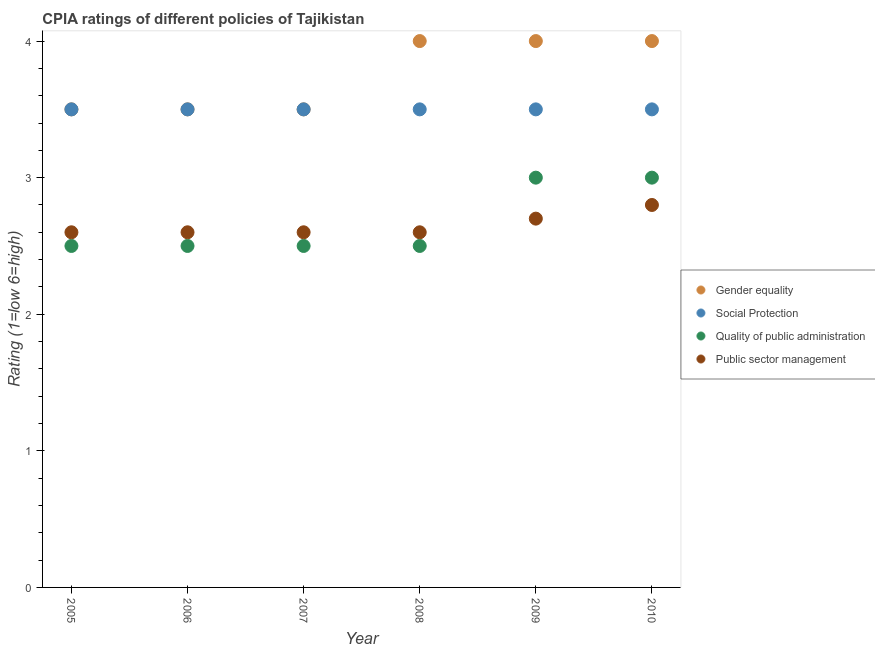What is the cpia rating of social protection in 2010?
Ensure brevity in your answer.  3.5. In which year was the cpia rating of quality of public administration minimum?
Provide a succinct answer. 2005. What is the total cpia rating of gender equality in the graph?
Offer a terse response. 22.5. What is the difference between the cpia rating of social protection in 2006 and that in 2009?
Offer a very short reply. 0. What is the difference between the cpia rating of social protection in 2007 and the cpia rating of public sector management in 2008?
Ensure brevity in your answer.  0.9. What is the average cpia rating of gender equality per year?
Make the answer very short. 3.75. In the year 2008, what is the difference between the cpia rating of social protection and cpia rating of public sector management?
Provide a succinct answer. 0.9. Is the cpia rating of social protection in 2008 less than that in 2010?
Give a very brief answer. No. Is the difference between the cpia rating of gender equality in 2005 and 2007 greater than the difference between the cpia rating of public sector management in 2005 and 2007?
Provide a short and direct response. No. What is the difference between the highest and the second highest cpia rating of quality of public administration?
Offer a very short reply. 0. In how many years, is the cpia rating of social protection greater than the average cpia rating of social protection taken over all years?
Your response must be concise. 0. Is the sum of the cpia rating of public sector management in 2005 and 2008 greater than the maximum cpia rating of social protection across all years?
Your answer should be compact. Yes. Is it the case that in every year, the sum of the cpia rating of gender equality and cpia rating of quality of public administration is greater than the sum of cpia rating of social protection and cpia rating of public sector management?
Your answer should be compact. Yes. Is it the case that in every year, the sum of the cpia rating of gender equality and cpia rating of social protection is greater than the cpia rating of quality of public administration?
Your answer should be very brief. Yes. Does the cpia rating of gender equality monotonically increase over the years?
Ensure brevity in your answer.  No. Is the cpia rating of public sector management strictly greater than the cpia rating of gender equality over the years?
Offer a very short reply. No. Is the cpia rating of quality of public administration strictly less than the cpia rating of gender equality over the years?
Make the answer very short. Yes. How many years are there in the graph?
Your answer should be very brief. 6. What is the difference between two consecutive major ticks on the Y-axis?
Offer a terse response. 1. Does the graph contain grids?
Provide a succinct answer. No. How many legend labels are there?
Your answer should be compact. 4. What is the title of the graph?
Offer a very short reply. CPIA ratings of different policies of Tajikistan. What is the label or title of the X-axis?
Keep it short and to the point. Year. What is the label or title of the Y-axis?
Ensure brevity in your answer.  Rating (1=low 6=high). What is the Rating (1=low 6=high) of Social Protection in 2005?
Give a very brief answer. 3.5. What is the Rating (1=low 6=high) of Gender equality in 2006?
Your answer should be compact. 3.5. What is the Rating (1=low 6=high) of Social Protection in 2007?
Your answer should be compact. 3.5. What is the Rating (1=low 6=high) in Gender equality in 2008?
Your answer should be very brief. 4. What is the Rating (1=low 6=high) in Social Protection in 2008?
Give a very brief answer. 3.5. What is the Rating (1=low 6=high) in Quality of public administration in 2008?
Offer a very short reply. 2.5. What is the Rating (1=low 6=high) of Public sector management in 2008?
Keep it short and to the point. 2.6. What is the Rating (1=low 6=high) in Social Protection in 2009?
Provide a short and direct response. 3.5. What is the Rating (1=low 6=high) in Social Protection in 2010?
Keep it short and to the point. 3.5. What is the Rating (1=low 6=high) in Quality of public administration in 2010?
Ensure brevity in your answer.  3. Across all years, what is the maximum Rating (1=low 6=high) of Gender equality?
Provide a short and direct response. 4. Across all years, what is the minimum Rating (1=low 6=high) in Public sector management?
Make the answer very short. 2.6. What is the total Rating (1=low 6=high) of Gender equality in the graph?
Provide a succinct answer. 22.5. What is the total Rating (1=low 6=high) in Social Protection in the graph?
Provide a succinct answer. 21. What is the total Rating (1=low 6=high) of Public sector management in the graph?
Provide a short and direct response. 15.9. What is the difference between the Rating (1=low 6=high) in Social Protection in 2005 and that in 2006?
Offer a very short reply. 0. What is the difference between the Rating (1=low 6=high) of Quality of public administration in 2005 and that in 2006?
Provide a short and direct response. 0. What is the difference between the Rating (1=low 6=high) in Gender equality in 2005 and that in 2007?
Make the answer very short. 0. What is the difference between the Rating (1=low 6=high) of Public sector management in 2005 and that in 2007?
Offer a terse response. 0. What is the difference between the Rating (1=low 6=high) of Social Protection in 2005 and that in 2008?
Provide a succinct answer. 0. What is the difference between the Rating (1=low 6=high) in Public sector management in 2005 and that in 2008?
Provide a short and direct response. 0. What is the difference between the Rating (1=low 6=high) of Gender equality in 2005 and that in 2009?
Provide a short and direct response. -0.5. What is the difference between the Rating (1=low 6=high) of Social Protection in 2005 and that in 2009?
Provide a succinct answer. 0. What is the difference between the Rating (1=low 6=high) of Quality of public administration in 2005 and that in 2009?
Provide a short and direct response. -0.5. What is the difference between the Rating (1=low 6=high) of Quality of public administration in 2005 and that in 2010?
Offer a terse response. -0.5. What is the difference between the Rating (1=low 6=high) of Public sector management in 2005 and that in 2010?
Give a very brief answer. -0.2. What is the difference between the Rating (1=low 6=high) in Gender equality in 2006 and that in 2007?
Your answer should be compact. 0. What is the difference between the Rating (1=low 6=high) of Social Protection in 2006 and that in 2007?
Your answer should be very brief. 0. What is the difference between the Rating (1=low 6=high) of Quality of public administration in 2006 and that in 2008?
Your answer should be very brief. 0. What is the difference between the Rating (1=low 6=high) of Public sector management in 2006 and that in 2008?
Your answer should be very brief. 0. What is the difference between the Rating (1=low 6=high) of Gender equality in 2006 and that in 2009?
Your answer should be very brief. -0.5. What is the difference between the Rating (1=low 6=high) in Quality of public administration in 2006 and that in 2009?
Give a very brief answer. -0.5. What is the difference between the Rating (1=low 6=high) in Public sector management in 2006 and that in 2009?
Give a very brief answer. -0.1. What is the difference between the Rating (1=low 6=high) in Quality of public administration in 2007 and that in 2008?
Provide a short and direct response. 0. What is the difference between the Rating (1=low 6=high) of Gender equality in 2007 and that in 2009?
Offer a terse response. -0.5. What is the difference between the Rating (1=low 6=high) of Social Protection in 2007 and that in 2009?
Your response must be concise. 0. What is the difference between the Rating (1=low 6=high) of Quality of public administration in 2007 and that in 2010?
Offer a very short reply. -0.5. What is the difference between the Rating (1=low 6=high) in Public sector management in 2007 and that in 2010?
Ensure brevity in your answer.  -0.2. What is the difference between the Rating (1=low 6=high) of Social Protection in 2008 and that in 2009?
Offer a terse response. 0. What is the difference between the Rating (1=low 6=high) of Quality of public administration in 2008 and that in 2009?
Your response must be concise. -0.5. What is the difference between the Rating (1=low 6=high) in Gender equality in 2008 and that in 2010?
Provide a succinct answer. 0. What is the difference between the Rating (1=low 6=high) of Social Protection in 2009 and that in 2010?
Keep it short and to the point. 0. What is the difference between the Rating (1=low 6=high) of Gender equality in 2005 and the Rating (1=low 6=high) of Social Protection in 2006?
Provide a short and direct response. 0. What is the difference between the Rating (1=low 6=high) of Quality of public administration in 2005 and the Rating (1=low 6=high) of Public sector management in 2006?
Provide a short and direct response. -0.1. What is the difference between the Rating (1=low 6=high) in Gender equality in 2005 and the Rating (1=low 6=high) in Social Protection in 2007?
Your answer should be very brief. 0. What is the difference between the Rating (1=low 6=high) in Social Protection in 2005 and the Rating (1=low 6=high) in Public sector management in 2007?
Your response must be concise. 0.9. What is the difference between the Rating (1=low 6=high) of Quality of public administration in 2005 and the Rating (1=low 6=high) of Public sector management in 2007?
Make the answer very short. -0.1. What is the difference between the Rating (1=low 6=high) of Gender equality in 2005 and the Rating (1=low 6=high) of Public sector management in 2008?
Provide a short and direct response. 0.9. What is the difference between the Rating (1=low 6=high) of Gender equality in 2005 and the Rating (1=low 6=high) of Social Protection in 2009?
Your answer should be very brief. 0. What is the difference between the Rating (1=low 6=high) of Gender equality in 2005 and the Rating (1=low 6=high) of Quality of public administration in 2009?
Provide a short and direct response. 0.5. What is the difference between the Rating (1=low 6=high) of Gender equality in 2005 and the Rating (1=low 6=high) of Public sector management in 2009?
Provide a succinct answer. 0.8. What is the difference between the Rating (1=low 6=high) of Quality of public administration in 2005 and the Rating (1=low 6=high) of Public sector management in 2009?
Your answer should be compact. -0.2. What is the difference between the Rating (1=low 6=high) of Gender equality in 2005 and the Rating (1=low 6=high) of Social Protection in 2010?
Provide a succinct answer. 0. What is the difference between the Rating (1=low 6=high) in Gender equality in 2005 and the Rating (1=low 6=high) in Quality of public administration in 2010?
Offer a very short reply. 0.5. What is the difference between the Rating (1=low 6=high) in Gender equality in 2006 and the Rating (1=low 6=high) in Social Protection in 2007?
Ensure brevity in your answer.  0. What is the difference between the Rating (1=low 6=high) of Gender equality in 2006 and the Rating (1=low 6=high) of Quality of public administration in 2007?
Offer a terse response. 1. What is the difference between the Rating (1=low 6=high) of Gender equality in 2006 and the Rating (1=low 6=high) of Public sector management in 2007?
Provide a succinct answer. 0.9. What is the difference between the Rating (1=low 6=high) of Quality of public administration in 2006 and the Rating (1=low 6=high) of Public sector management in 2007?
Provide a short and direct response. -0.1. What is the difference between the Rating (1=low 6=high) of Gender equality in 2006 and the Rating (1=low 6=high) of Social Protection in 2008?
Give a very brief answer. 0. What is the difference between the Rating (1=low 6=high) of Quality of public administration in 2006 and the Rating (1=low 6=high) of Public sector management in 2008?
Make the answer very short. -0.1. What is the difference between the Rating (1=low 6=high) of Gender equality in 2006 and the Rating (1=low 6=high) of Quality of public administration in 2009?
Keep it short and to the point. 0.5. What is the difference between the Rating (1=low 6=high) of Gender equality in 2006 and the Rating (1=low 6=high) of Public sector management in 2009?
Ensure brevity in your answer.  0.8. What is the difference between the Rating (1=low 6=high) of Social Protection in 2006 and the Rating (1=low 6=high) of Quality of public administration in 2009?
Your answer should be very brief. 0.5. What is the difference between the Rating (1=low 6=high) of Social Protection in 2006 and the Rating (1=low 6=high) of Public sector management in 2009?
Your response must be concise. 0.8. What is the difference between the Rating (1=low 6=high) of Gender equality in 2006 and the Rating (1=low 6=high) of Social Protection in 2010?
Your answer should be compact. 0. What is the difference between the Rating (1=low 6=high) of Gender equality in 2006 and the Rating (1=low 6=high) of Quality of public administration in 2010?
Offer a terse response. 0.5. What is the difference between the Rating (1=low 6=high) in Gender equality in 2006 and the Rating (1=low 6=high) in Public sector management in 2010?
Your answer should be very brief. 0.7. What is the difference between the Rating (1=low 6=high) in Quality of public administration in 2006 and the Rating (1=low 6=high) in Public sector management in 2010?
Give a very brief answer. -0.3. What is the difference between the Rating (1=low 6=high) in Gender equality in 2007 and the Rating (1=low 6=high) in Social Protection in 2008?
Give a very brief answer. 0. What is the difference between the Rating (1=low 6=high) in Gender equality in 2007 and the Rating (1=low 6=high) in Quality of public administration in 2008?
Your answer should be very brief. 1. What is the difference between the Rating (1=low 6=high) of Social Protection in 2007 and the Rating (1=low 6=high) of Public sector management in 2008?
Your answer should be compact. 0.9. What is the difference between the Rating (1=low 6=high) of Quality of public administration in 2007 and the Rating (1=low 6=high) of Public sector management in 2008?
Your answer should be very brief. -0.1. What is the difference between the Rating (1=low 6=high) of Gender equality in 2007 and the Rating (1=low 6=high) of Social Protection in 2009?
Keep it short and to the point. 0. What is the difference between the Rating (1=low 6=high) of Social Protection in 2007 and the Rating (1=low 6=high) of Quality of public administration in 2009?
Your response must be concise. 0.5. What is the difference between the Rating (1=low 6=high) of Social Protection in 2007 and the Rating (1=low 6=high) of Public sector management in 2009?
Your answer should be very brief. 0.8. What is the difference between the Rating (1=low 6=high) in Quality of public administration in 2007 and the Rating (1=low 6=high) in Public sector management in 2009?
Offer a very short reply. -0.2. What is the difference between the Rating (1=low 6=high) in Gender equality in 2007 and the Rating (1=low 6=high) in Social Protection in 2010?
Offer a terse response. 0. What is the difference between the Rating (1=low 6=high) of Gender equality in 2007 and the Rating (1=low 6=high) of Public sector management in 2010?
Keep it short and to the point. 0.7. What is the difference between the Rating (1=low 6=high) in Social Protection in 2007 and the Rating (1=low 6=high) in Public sector management in 2010?
Your response must be concise. 0.7. What is the difference between the Rating (1=low 6=high) in Quality of public administration in 2007 and the Rating (1=low 6=high) in Public sector management in 2010?
Ensure brevity in your answer.  -0.3. What is the difference between the Rating (1=low 6=high) of Gender equality in 2008 and the Rating (1=low 6=high) of Social Protection in 2009?
Offer a very short reply. 0.5. What is the difference between the Rating (1=low 6=high) of Social Protection in 2008 and the Rating (1=low 6=high) of Quality of public administration in 2009?
Your answer should be compact. 0.5. What is the difference between the Rating (1=low 6=high) of Quality of public administration in 2008 and the Rating (1=low 6=high) of Public sector management in 2009?
Offer a terse response. -0.2. What is the difference between the Rating (1=low 6=high) of Gender equality in 2008 and the Rating (1=low 6=high) of Social Protection in 2010?
Ensure brevity in your answer.  0.5. What is the difference between the Rating (1=low 6=high) in Gender equality in 2008 and the Rating (1=low 6=high) in Quality of public administration in 2010?
Offer a very short reply. 1. What is the difference between the Rating (1=low 6=high) of Gender equality in 2008 and the Rating (1=low 6=high) of Public sector management in 2010?
Ensure brevity in your answer.  1.2. What is the difference between the Rating (1=low 6=high) in Social Protection in 2008 and the Rating (1=low 6=high) in Quality of public administration in 2010?
Your answer should be compact. 0.5. What is the difference between the Rating (1=low 6=high) of Social Protection in 2008 and the Rating (1=low 6=high) of Public sector management in 2010?
Offer a very short reply. 0.7. What is the difference between the Rating (1=low 6=high) in Gender equality in 2009 and the Rating (1=low 6=high) in Quality of public administration in 2010?
Ensure brevity in your answer.  1. What is the difference between the Rating (1=low 6=high) of Social Protection in 2009 and the Rating (1=low 6=high) of Quality of public administration in 2010?
Offer a very short reply. 0.5. What is the average Rating (1=low 6=high) in Gender equality per year?
Your answer should be compact. 3.75. What is the average Rating (1=low 6=high) in Social Protection per year?
Your response must be concise. 3.5. What is the average Rating (1=low 6=high) in Quality of public administration per year?
Your answer should be compact. 2.67. What is the average Rating (1=low 6=high) of Public sector management per year?
Give a very brief answer. 2.65. In the year 2005, what is the difference between the Rating (1=low 6=high) in Gender equality and Rating (1=low 6=high) in Quality of public administration?
Keep it short and to the point. 1. In the year 2005, what is the difference between the Rating (1=low 6=high) of Gender equality and Rating (1=low 6=high) of Public sector management?
Your answer should be very brief. 0.9. In the year 2005, what is the difference between the Rating (1=low 6=high) in Quality of public administration and Rating (1=low 6=high) in Public sector management?
Your answer should be very brief. -0.1. In the year 2006, what is the difference between the Rating (1=low 6=high) of Gender equality and Rating (1=low 6=high) of Social Protection?
Make the answer very short. 0. In the year 2006, what is the difference between the Rating (1=low 6=high) in Gender equality and Rating (1=low 6=high) in Public sector management?
Your answer should be very brief. 0.9. In the year 2006, what is the difference between the Rating (1=low 6=high) in Quality of public administration and Rating (1=low 6=high) in Public sector management?
Offer a very short reply. -0.1. In the year 2007, what is the difference between the Rating (1=low 6=high) in Gender equality and Rating (1=low 6=high) in Social Protection?
Offer a very short reply. 0. In the year 2007, what is the difference between the Rating (1=low 6=high) of Gender equality and Rating (1=low 6=high) of Public sector management?
Your response must be concise. 0.9. In the year 2007, what is the difference between the Rating (1=low 6=high) in Social Protection and Rating (1=low 6=high) in Public sector management?
Give a very brief answer. 0.9. In the year 2007, what is the difference between the Rating (1=low 6=high) of Quality of public administration and Rating (1=low 6=high) of Public sector management?
Offer a terse response. -0.1. In the year 2008, what is the difference between the Rating (1=low 6=high) in Gender equality and Rating (1=low 6=high) in Quality of public administration?
Offer a terse response. 1.5. In the year 2008, what is the difference between the Rating (1=low 6=high) in Social Protection and Rating (1=low 6=high) in Quality of public administration?
Offer a very short reply. 1. In the year 2009, what is the difference between the Rating (1=low 6=high) of Gender equality and Rating (1=low 6=high) of Social Protection?
Keep it short and to the point. 0.5. In the year 2009, what is the difference between the Rating (1=low 6=high) of Social Protection and Rating (1=low 6=high) of Quality of public administration?
Provide a succinct answer. 0.5. In the year 2009, what is the difference between the Rating (1=low 6=high) of Social Protection and Rating (1=low 6=high) of Public sector management?
Provide a short and direct response. 0.8. In the year 2010, what is the difference between the Rating (1=low 6=high) in Gender equality and Rating (1=low 6=high) in Public sector management?
Offer a very short reply. 1.2. In the year 2010, what is the difference between the Rating (1=low 6=high) in Social Protection and Rating (1=low 6=high) in Public sector management?
Keep it short and to the point. 0.7. What is the ratio of the Rating (1=low 6=high) in Gender equality in 2005 to that in 2006?
Make the answer very short. 1. What is the ratio of the Rating (1=low 6=high) of Gender equality in 2005 to that in 2007?
Your response must be concise. 1. What is the ratio of the Rating (1=low 6=high) in Social Protection in 2005 to that in 2007?
Provide a short and direct response. 1. What is the ratio of the Rating (1=low 6=high) of Social Protection in 2005 to that in 2008?
Offer a very short reply. 1. What is the ratio of the Rating (1=low 6=high) in Quality of public administration in 2005 to that in 2008?
Your response must be concise. 1. What is the ratio of the Rating (1=low 6=high) in Public sector management in 2005 to that in 2008?
Ensure brevity in your answer.  1. What is the ratio of the Rating (1=low 6=high) in Gender equality in 2005 to that in 2009?
Provide a succinct answer. 0.88. What is the ratio of the Rating (1=low 6=high) in Gender equality in 2005 to that in 2010?
Offer a terse response. 0.88. What is the ratio of the Rating (1=low 6=high) in Social Protection in 2005 to that in 2010?
Provide a succinct answer. 1. What is the ratio of the Rating (1=low 6=high) in Quality of public administration in 2005 to that in 2010?
Your response must be concise. 0.83. What is the ratio of the Rating (1=low 6=high) in Gender equality in 2006 to that in 2007?
Give a very brief answer. 1. What is the ratio of the Rating (1=low 6=high) in Social Protection in 2006 to that in 2007?
Your answer should be compact. 1. What is the ratio of the Rating (1=low 6=high) of Quality of public administration in 2006 to that in 2007?
Ensure brevity in your answer.  1. What is the ratio of the Rating (1=low 6=high) of Quality of public administration in 2006 to that in 2009?
Provide a short and direct response. 0.83. What is the ratio of the Rating (1=low 6=high) in Social Protection in 2006 to that in 2010?
Keep it short and to the point. 1. What is the ratio of the Rating (1=low 6=high) in Public sector management in 2006 to that in 2010?
Make the answer very short. 0.93. What is the ratio of the Rating (1=low 6=high) in Social Protection in 2007 to that in 2008?
Offer a very short reply. 1. What is the ratio of the Rating (1=low 6=high) of Social Protection in 2007 to that in 2009?
Offer a very short reply. 1. What is the ratio of the Rating (1=low 6=high) in Quality of public administration in 2007 to that in 2009?
Offer a terse response. 0.83. What is the ratio of the Rating (1=low 6=high) in Gender equality in 2007 to that in 2010?
Provide a succinct answer. 0.88. What is the ratio of the Rating (1=low 6=high) in Public sector management in 2007 to that in 2010?
Make the answer very short. 0.93. What is the ratio of the Rating (1=low 6=high) of Social Protection in 2008 to that in 2009?
Provide a short and direct response. 1. What is the ratio of the Rating (1=low 6=high) of Quality of public administration in 2008 to that in 2009?
Offer a terse response. 0.83. What is the ratio of the Rating (1=low 6=high) in Gender equality in 2008 to that in 2010?
Offer a terse response. 1. What is the ratio of the Rating (1=low 6=high) in Social Protection in 2008 to that in 2010?
Offer a terse response. 1. What is the ratio of the Rating (1=low 6=high) in Public sector management in 2008 to that in 2010?
Give a very brief answer. 0.93. What is the ratio of the Rating (1=low 6=high) in Public sector management in 2009 to that in 2010?
Ensure brevity in your answer.  0.96. What is the difference between the highest and the second highest Rating (1=low 6=high) of Gender equality?
Make the answer very short. 0. What is the difference between the highest and the second highest Rating (1=low 6=high) of Quality of public administration?
Keep it short and to the point. 0. What is the difference between the highest and the second highest Rating (1=low 6=high) in Public sector management?
Provide a short and direct response. 0.1. What is the difference between the highest and the lowest Rating (1=low 6=high) of Gender equality?
Offer a terse response. 0.5. What is the difference between the highest and the lowest Rating (1=low 6=high) in Social Protection?
Provide a succinct answer. 0. What is the difference between the highest and the lowest Rating (1=low 6=high) of Quality of public administration?
Offer a very short reply. 0.5. 